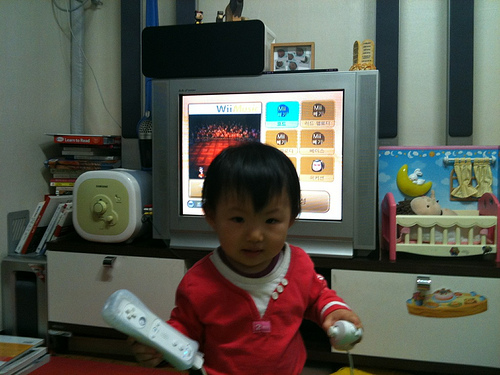Please identify all text content in this image. Wii 